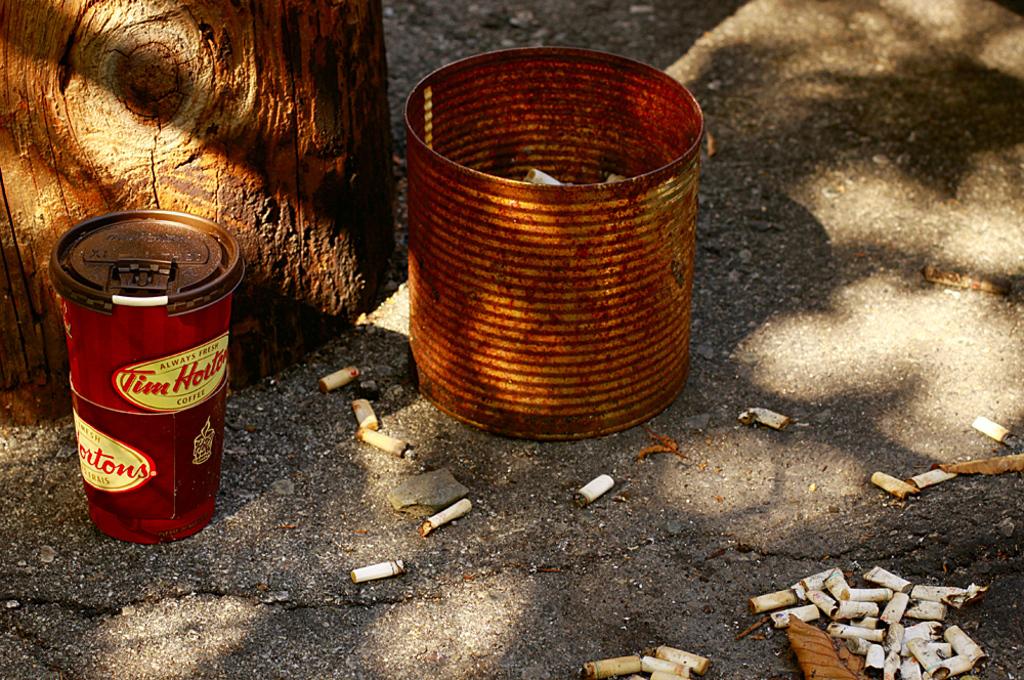What store is that coffee from?
Provide a short and direct response. Tim hortons. Is this a tim hortons cup?
Offer a terse response. Yes. 